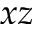Convert formula to latex. <formula><loc_0><loc_0><loc_500><loc_500>x z</formula> 